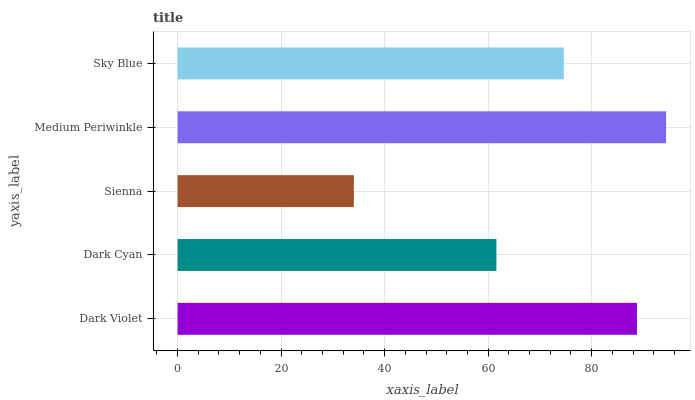Is Sienna the minimum?
Answer yes or no. Yes. Is Medium Periwinkle the maximum?
Answer yes or no. Yes. Is Dark Cyan the minimum?
Answer yes or no. No. Is Dark Cyan the maximum?
Answer yes or no. No. Is Dark Violet greater than Dark Cyan?
Answer yes or no. Yes. Is Dark Cyan less than Dark Violet?
Answer yes or no. Yes. Is Dark Cyan greater than Dark Violet?
Answer yes or no. No. Is Dark Violet less than Dark Cyan?
Answer yes or no. No. Is Sky Blue the high median?
Answer yes or no. Yes. Is Sky Blue the low median?
Answer yes or no. Yes. Is Medium Periwinkle the high median?
Answer yes or no. No. Is Medium Periwinkle the low median?
Answer yes or no. No. 